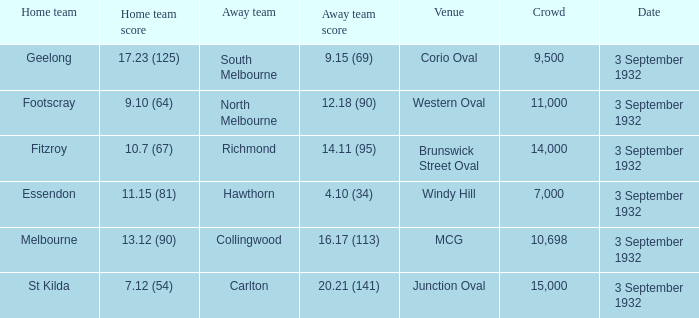What is the Home team score for the Away team of North Melbourne? 9.10 (64). 